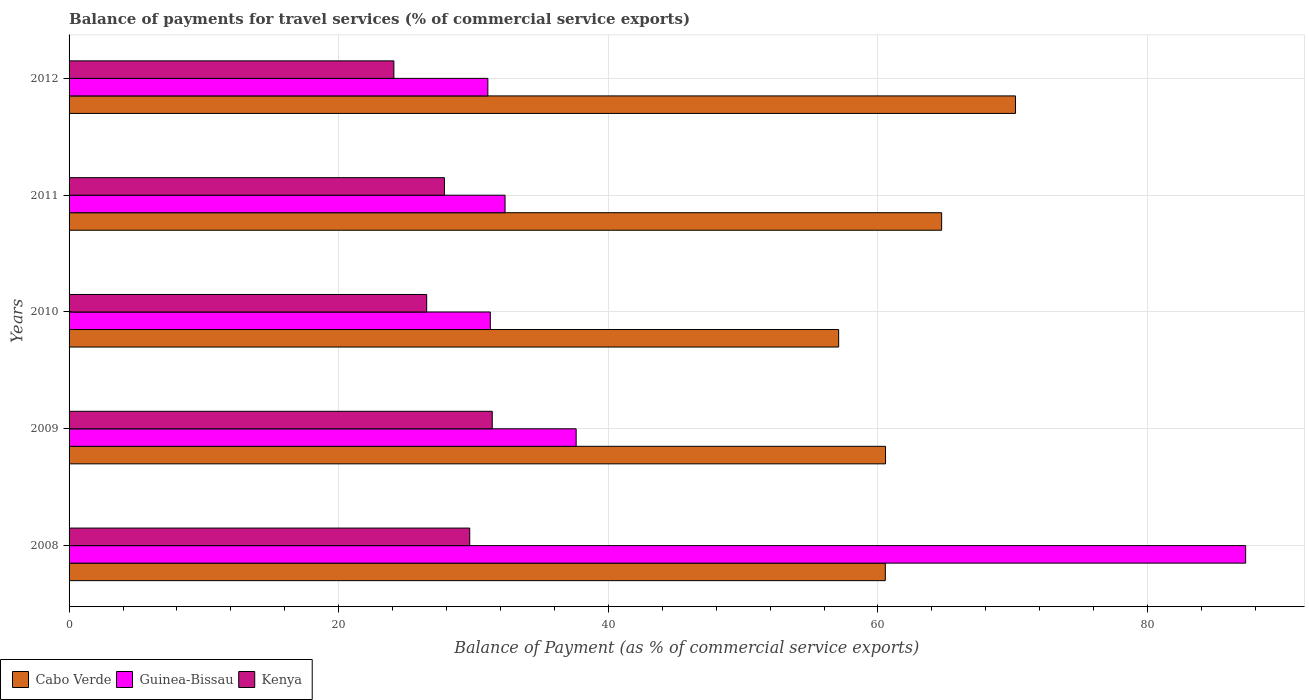How many different coloured bars are there?
Offer a very short reply. 3. What is the label of the 4th group of bars from the top?
Your response must be concise. 2009. What is the balance of payments for travel services in Cabo Verde in 2011?
Your response must be concise. 64.72. Across all years, what is the maximum balance of payments for travel services in Cabo Verde?
Give a very brief answer. 70.2. Across all years, what is the minimum balance of payments for travel services in Guinea-Bissau?
Your answer should be very brief. 31.06. In which year was the balance of payments for travel services in Cabo Verde maximum?
Your answer should be compact. 2012. What is the total balance of payments for travel services in Kenya in the graph?
Your answer should be very brief. 139.57. What is the difference between the balance of payments for travel services in Cabo Verde in 2008 and that in 2012?
Provide a succinct answer. -9.66. What is the difference between the balance of payments for travel services in Kenya in 2010 and the balance of payments for travel services in Cabo Verde in 2009?
Provide a short and direct response. -34.04. What is the average balance of payments for travel services in Guinea-Bissau per year?
Make the answer very short. 43.91. In the year 2010, what is the difference between the balance of payments for travel services in Kenya and balance of payments for travel services in Guinea-Bissau?
Your answer should be very brief. -4.72. In how many years, is the balance of payments for travel services in Kenya greater than 68 %?
Your answer should be compact. 0. What is the ratio of the balance of payments for travel services in Cabo Verde in 2008 to that in 2012?
Make the answer very short. 0.86. Is the balance of payments for travel services in Kenya in 2008 less than that in 2011?
Your answer should be very brief. No. Is the difference between the balance of payments for travel services in Kenya in 2009 and 2012 greater than the difference between the balance of payments for travel services in Guinea-Bissau in 2009 and 2012?
Your response must be concise. Yes. What is the difference between the highest and the second highest balance of payments for travel services in Kenya?
Make the answer very short. 1.67. What is the difference between the highest and the lowest balance of payments for travel services in Cabo Verde?
Keep it short and to the point. 13.12. In how many years, is the balance of payments for travel services in Kenya greater than the average balance of payments for travel services in Kenya taken over all years?
Ensure brevity in your answer.  2. Is the sum of the balance of payments for travel services in Kenya in 2008 and 2012 greater than the maximum balance of payments for travel services in Guinea-Bissau across all years?
Make the answer very short. No. What does the 1st bar from the top in 2009 represents?
Make the answer very short. Kenya. What does the 1st bar from the bottom in 2012 represents?
Give a very brief answer. Cabo Verde. How many bars are there?
Your answer should be very brief. 15. Are all the bars in the graph horizontal?
Offer a very short reply. Yes. Are the values on the major ticks of X-axis written in scientific E-notation?
Offer a terse response. No. Does the graph contain any zero values?
Offer a very short reply. No. How many legend labels are there?
Provide a short and direct response. 3. How are the legend labels stacked?
Ensure brevity in your answer.  Horizontal. What is the title of the graph?
Your answer should be very brief. Balance of payments for travel services (% of commercial service exports). What is the label or title of the X-axis?
Provide a short and direct response. Balance of Payment (as % of commercial service exports). What is the Balance of Payment (as % of commercial service exports) of Cabo Verde in 2008?
Give a very brief answer. 60.55. What is the Balance of Payment (as % of commercial service exports) of Guinea-Bissau in 2008?
Your answer should be very brief. 87.27. What is the Balance of Payment (as % of commercial service exports) of Kenya in 2008?
Your answer should be compact. 29.72. What is the Balance of Payment (as % of commercial service exports) in Cabo Verde in 2009?
Make the answer very short. 60.56. What is the Balance of Payment (as % of commercial service exports) in Guinea-Bissau in 2009?
Offer a very short reply. 37.61. What is the Balance of Payment (as % of commercial service exports) of Kenya in 2009?
Make the answer very short. 31.39. What is the Balance of Payment (as % of commercial service exports) in Cabo Verde in 2010?
Ensure brevity in your answer.  57.08. What is the Balance of Payment (as % of commercial service exports) of Guinea-Bissau in 2010?
Give a very brief answer. 31.25. What is the Balance of Payment (as % of commercial service exports) of Kenya in 2010?
Ensure brevity in your answer.  26.53. What is the Balance of Payment (as % of commercial service exports) of Cabo Verde in 2011?
Keep it short and to the point. 64.72. What is the Balance of Payment (as % of commercial service exports) in Guinea-Bissau in 2011?
Make the answer very short. 32.34. What is the Balance of Payment (as % of commercial service exports) in Kenya in 2011?
Offer a terse response. 27.84. What is the Balance of Payment (as % of commercial service exports) in Cabo Verde in 2012?
Offer a very short reply. 70.2. What is the Balance of Payment (as % of commercial service exports) in Guinea-Bissau in 2012?
Your answer should be compact. 31.06. What is the Balance of Payment (as % of commercial service exports) in Kenya in 2012?
Your answer should be compact. 24.09. Across all years, what is the maximum Balance of Payment (as % of commercial service exports) of Cabo Verde?
Provide a succinct answer. 70.2. Across all years, what is the maximum Balance of Payment (as % of commercial service exports) of Guinea-Bissau?
Keep it short and to the point. 87.27. Across all years, what is the maximum Balance of Payment (as % of commercial service exports) in Kenya?
Keep it short and to the point. 31.39. Across all years, what is the minimum Balance of Payment (as % of commercial service exports) in Cabo Verde?
Provide a succinct answer. 57.08. Across all years, what is the minimum Balance of Payment (as % of commercial service exports) in Guinea-Bissau?
Provide a short and direct response. 31.06. Across all years, what is the minimum Balance of Payment (as % of commercial service exports) of Kenya?
Provide a short and direct response. 24.09. What is the total Balance of Payment (as % of commercial service exports) of Cabo Verde in the graph?
Offer a terse response. 313.12. What is the total Balance of Payment (as % of commercial service exports) of Guinea-Bissau in the graph?
Make the answer very short. 219.54. What is the total Balance of Payment (as % of commercial service exports) in Kenya in the graph?
Provide a short and direct response. 139.57. What is the difference between the Balance of Payment (as % of commercial service exports) in Cabo Verde in 2008 and that in 2009?
Provide a succinct answer. -0.02. What is the difference between the Balance of Payment (as % of commercial service exports) of Guinea-Bissau in 2008 and that in 2009?
Provide a succinct answer. 49.66. What is the difference between the Balance of Payment (as % of commercial service exports) of Kenya in 2008 and that in 2009?
Provide a short and direct response. -1.67. What is the difference between the Balance of Payment (as % of commercial service exports) of Cabo Verde in 2008 and that in 2010?
Your response must be concise. 3.46. What is the difference between the Balance of Payment (as % of commercial service exports) of Guinea-Bissau in 2008 and that in 2010?
Ensure brevity in your answer.  56.03. What is the difference between the Balance of Payment (as % of commercial service exports) of Kenya in 2008 and that in 2010?
Make the answer very short. 3.19. What is the difference between the Balance of Payment (as % of commercial service exports) of Cabo Verde in 2008 and that in 2011?
Provide a succinct answer. -4.18. What is the difference between the Balance of Payment (as % of commercial service exports) of Guinea-Bissau in 2008 and that in 2011?
Ensure brevity in your answer.  54.94. What is the difference between the Balance of Payment (as % of commercial service exports) in Kenya in 2008 and that in 2011?
Provide a succinct answer. 1.88. What is the difference between the Balance of Payment (as % of commercial service exports) of Cabo Verde in 2008 and that in 2012?
Provide a short and direct response. -9.66. What is the difference between the Balance of Payment (as % of commercial service exports) of Guinea-Bissau in 2008 and that in 2012?
Provide a short and direct response. 56.21. What is the difference between the Balance of Payment (as % of commercial service exports) of Kenya in 2008 and that in 2012?
Give a very brief answer. 5.63. What is the difference between the Balance of Payment (as % of commercial service exports) of Cabo Verde in 2009 and that in 2010?
Ensure brevity in your answer.  3.48. What is the difference between the Balance of Payment (as % of commercial service exports) in Guinea-Bissau in 2009 and that in 2010?
Your answer should be very brief. 6.37. What is the difference between the Balance of Payment (as % of commercial service exports) of Kenya in 2009 and that in 2010?
Your answer should be very brief. 4.86. What is the difference between the Balance of Payment (as % of commercial service exports) of Cabo Verde in 2009 and that in 2011?
Offer a terse response. -4.16. What is the difference between the Balance of Payment (as % of commercial service exports) of Guinea-Bissau in 2009 and that in 2011?
Your answer should be very brief. 5.27. What is the difference between the Balance of Payment (as % of commercial service exports) in Kenya in 2009 and that in 2011?
Provide a short and direct response. 3.55. What is the difference between the Balance of Payment (as % of commercial service exports) of Cabo Verde in 2009 and that in 2012?
Offer a terse response. -9.64. What is the difference between the Balance of Payment (as % of commercial service exports) in Guinea-Bissau in 2009 and that in 2012?
Your response must be concise. 6.55. What is the difference between the Balance of Payment (as % of commercial service exports) in Kenya in 2009 and that in 2012?
Offer a terse response. 7.3. What is the difference between the Balance of Payment (as % of commercial service exports) of Cabo Verde in 2010 and that in 2011?
Your answer should be very brief. -7.64. What is the difference between the Balance of Payment (as % of commercial service exports) of Guinea-Bissau in 2010 and that in 2011?
Your answer should be very brief. -1.09. What is the difference between the Balance of Payment (as % of commercial service exports) in Kenya in 2010 and that in 2011?
Make the answer very short. -1.32. What is the difference between the Balance of Payment (as % of commercial service exports) of Cabo Verde in 2010 and that in 2012?
Offer a very short reply. -13.12. What is the difference between the Balance of Payment (as % of commercial service exports) in Guinea-Bissau in 2010 and that in 2012?
Provide a succinct answer. 0.18. What is the difference between the Balance of Payment (as % of commercial service exports) in Kenya in 2010 and that in 2012?
Offer a very short reply. 2.43. What is the difference between the Balance of Payment (as % of commercial service exports) of Cabo Verde in 2011 and that in 2012?
Your answer should be compact. -5.48. What is the difference between the Balance of Payment (as % of commercial service exports) of Guinea-Bissau in 2011 and that in 2012?
Your answer should be compact. 1.28. What is the difference between the Balance of Payment (as % of commercial service exports) of Kenya in 2011 and that in 2012?
Make the answer very short. 3.75. What is the difference between the Balance of Payment (as % of commercial service exports) in Cabo Verde in 2008 and the Balance of Payment (as % of commercial service exports) in Guinea-Bissau in 2009?
Ensure brevity in your answer.  22.93. What is the difference between the Balance of Payment (as % of commercial service exports) of Cabo Verde in 2008 and the Balance of Payment (as % of commercial service exports) of Kenya in 2009?
Make the answer very short. 29.16. What is the difference between the Balance of Payment (as % of commercial service exports) of Guinea-Bissau in 2008 and the Balance of Payment (as % of commercial service exports) of Kenya in 2009?
Keep it short and to the point. 55.88. What is the difference between the Balance of Payment (as % of commercial service exports) in Cabo Verde in 2008 and the Balance of Payment (as % of commercial service exports) in Guinea-Bissau in 2010?
Offer a terse response. 29.3. What is the difference between the Balance of Payment (as % of commercial service exports) in Cabo Verde in 2008 and the Balance of Payment (as % of commercial service exports) in Kenya in 2010?
Provide a short and direct response. 34.02. What is the difference between the Balance of Payment (as % of commercial service exports) of Guinea-Bissau in 2008 and the Balance of Payment (as % of commercial service exports) of Kenya in 2010?
Ensure brevity in your answer.  60.75. What is the difference between the Balance of Payment (as % of commercial service exports) in Cabo Verde in 2008 and the Balance of Payment (as % of commercial service exports) in Guinea-Bissau in 2011?
Your answer should be very brief. 28.21. What is the difference between the Balance of Payment (as % of commercial service exports) of Cabo Verde in 2008 and the Balance of Payment (as % of commercial service exports) of Kenya in 2011?
Offer a terse response. 32.7. What is the difference between the Balance of Payment (as % of commercial service exports) of Guinea-Bissau in 2008 and the Balance of Payment (as % of commercial service exports) of Kenya in 2011?
Make the answer very short. 59.43. What is the difference between the Balance of Payment (as % of commercial service exports) of Cabo Verde in 2008 and the Balance of Payment (as % of commercial service exports) of Guinea-Bissau in 2012?
Make the answer very short. 29.48. What is the difference between the Balance of Payment (as % of commercial service exports) in Cabo Verde in 2008 and the Balance of Payment (as % of commercial service exports) in Kenya in 2012?
Your response must be concise. 36.45. What is the difference between the Balance of Payment (as % of commercial service exports) of Guinea-Bissau in 2008 and the Balance of Payment (as % of commercial service exports) of Kenya in 2012?
Offer a terse response. 63.18. What is the difference between the Balance of Payment (as % of commercial service exports) in Cabo Verde in 2009 and the Balance of Payment (as % of commercial service exports) in Guinea-Bissau in 2010?
Provide a succinct answer. 29.32. What is the difference between the Balance of Payment (as % of commercial service exports) in Cabo Verde in 2009 and the Balance of Payment (as % of commercial service exports) in Kenya in 2010?
Your answer should be very brief. 34.04. What is the difference between the Balance of Payment (as % of commercial service exports) of Guinea-Bissau in 2009 and the Balance of Payment (as % of commercial service exports) of Kenya in 2010?
Make the answer very short. 11.09. What is the difference between the Balance of Payment (as % of commercial service exports) of Cabo Verde in 2009 and the Balance of Payment (as % of commercial service exports) of Guinea-Bissau in 2011?
Ensure brevity in your answer.  28.22. What is the difference between the Balance of Payment (as % of commercial service exports) of Cabo Verde in 2009 and the Balance of Payment (as % of commercial service exports) of Kenya in 2011?
Your answer should be compact. 32.72. What is the difference between the Balance of Payment (as % of commercial service exports) in Guinea-Bissau in 2009 and the Balance of Payment (as % of commercial service exports) in Kenya in 2011?
Offer a terse response. 9.77. What is the difference between the Balance of Payment (as % of commercial service exports) of Cabo Verde in 2009 and the Balance of Payment (as % of commercial service exports) of Guinea-Bissau in 2012?
Provide a succinct answer. 29.5. What is the difference between the Balance of Payment (as % of commercial service exports) of Cabo Verde in 2009 and the Balance of Payment (as % of commercial service exports) of Kenya in 2012?
Offer a very short reply. 36.47. What is the difference between the Balance of Payment (as % of commercial service exports) of Guinea-Bissau in 2009 and the Balance of Payment (as % of commercial service exports) of Kenya in 2012?
Make the answer very short. 13.52. What is the difference between the Balance of Payment (as % of commercial service exports) of Cabo Verde in 2010 and the Balance of Payment (as % of commercial service exports) of Guinea-Bissau in 2011?
Provide a succinct answer. 24.75. What is the difference between the Balance of Payment (as % of commercial service exports) in Cabo Verde in 2010 and the Balance of Payment (as % of commercial service exports) in Kenya in 2011?
Your answer should be very brief. 29.24. What is the difference between the Balance of Payment (as % of commercial service exports) in Guinea-Bissau in 2010 and the Balance of Payment (as % of commercial service exports) in Kenya in 2011?
Make the answer very short. 3.4. What is the difference between the Balance of Payment (as % of commercial service exports) in Cabo Verde in 2010 and the Balance of Payment (as % of commercial service exports) in Guinea-Bissau in 2012?
Offer a very short reply. 26.02. What is the difference between the Balance of Payment (as % of commercial service exports) in Cabo Verde in 2010 and the Balance of Payment (as % of commercial service exports) in Kenya in 2012?
Your response must be concise. 32.99. What is the difference between the Balance of Payment (as % of commercial service exports) in Guinea-Bissau in 2010 and the Balance of Payment (as % of commercial service exports) in Kenya in 2012?
Your answer should be compact. 7.15. What is the difference between the Balance of Payment (as % of commercial service exports) in Cabo Verde in 2011 and the Balance of Payment (as % of commercial service exports) in Guinea-Bissau in 2012?
Ensure brevity in your answer.  33.66. What is the difference between the Balance of Payment (as % of commercial service exports) in Cabo Verde in 2011 and the Balance of Payment (as % of commercial service exports) in Kenya in 2012?
Make the answer very short. 40.63. What is the difference between the Balance of Payment (as % of commercial service exports) of Guinea-Bissau in 2011 and the Balance of Payment (as % of commercial service exports) of Kenya in 2012?
Offer a very short reply. 8.25. What is the average Balance of Payment (as % of commercial service exports) in Cabo Verde per year?
Your answer should be very brief. 62.62. What is the average Balance of Payment (as % of commercial service exports) in Guinea-Bissau per year?
Your answer should be very brief. 43.91. What is the average Balance of Payment (as % of commercial service exports) in Kenya per year?
Your answer should be compact. 27.91. In the year 2008, what is the difference between the Balance of Payment (as % of commercial service exports) of Cabo Verde and Balance of Payment (as % of commercial service exports) of Guinea-Bissau?
Your answer should be compact. -26.73. In the year 2008, what is the difference between the Balance of Payment (as % of commercial service exports) in Cabo Verde and Balance of Payment (as % of commercial service exports) in Kenya?
Keep it short and to the point. 30.83. In the year 2008, what is the difference between the Balance of Payment (as % of commercial service exports) in Guinea-Bissau and Balance of Payment (as % of commercial service exports) in Kenya?
Provide a succinct answer. 57.56. In the year 2009, what is the difference between the Balance of Payment (as % of commercial service exports) in Cabo Verde and Balance of Payment (as % of commercial service exports) in Guinea-Bissau?
Keep it short and to the point. 22.95. In the year 2009, what is the difference between the Balance of Payment (as % of commercial service exports) in Cabo Verde and Balance of Payment (as % of commercial service exports) in Kenya?
Your answer should be very brief. 29.17. In the year 2009, what is the difference between the Balance of Payment (as % of commercial service exports) in Guinea-Bissau and Balance of Payment (as % of commercial service exports) in Kenya?
Give a very brief answer. 6.22. In the year 2010, what is the difference between the Balance of Payment (as % of commercial service exports) of Cabo Verde and Balance of Payment (as % of commercial service exports) of Guinea-Bissau?
Offer a terse response. 25.84. In the year 2010, what is the difference between the Balance of Payment (as % of commercial service exports) of Cabo Verde and Balance of Payment (as % of commercial service exports) of Kenya?
Give a very brief answer. 30.56. In the year 2010, what is the difference between the Balance of Payment (as % of commercial service exports) in Guinea-Bissau and Balance of Payment (as % of commercial service exports) in Kenya?
Provide a short and direct response. 4.72. In the year 2011, what is the difference between the Balance of Payment (as % of commercial service exports) of Cabo Verde and Balance of Payment (as % of commercial service exports) of Guinea-Bissau?
Give a very brief answer. 32.39. In the year 2011, what is the difference between the Balance of Payment (as % of commercial service exports) of Cabo Verde and Balance of Payment (as % of commercial service exports) of Kenya?
Your answer should be compact. 36.88. In the year 2011, what is the difference between the Balance of Payment (as % of commercial service exports) in Guinea-Bissau and Balance of Payment (as % of commercial service exports) in Kenya?
Offer a very short reply. 4.5. In the year 2012, what is the difference between the Balance of Payment (as % of commercial service exports) in Cabo Verde and Balance of Payment (as % of commercial service exports) in Guinea-Bissau?
Your answer should be compact. 39.14. In the year 2012, what is the difference between the Balance of Payment (as % of commercial service exports) in Cabo Verde and Balance of Payment (as % of commercial service exports) in Kenya?
Your answer should be compact. 46.11. In the year 2012, what is the difference between the Balance of Payment (as % of commercial service exports) of Guinea-Bissau and Balance of Payment (as % of commercial service exports) of Kenya?
Your answer should be compact. 6.97. What is the ratio of the Balance of Payment (as % of commercial service exports) in Cabo Verde in 2008 to that in 2009?
Ensure brevity in your answer.  1. What is the ratio of the Balance of Payment (as % of commercial service exports) in Guinea-Bissau in 2008 to that in 2009?
Give a very brief answer. 2.32. What is the ratio of the Balance of Payment (as % of commercial service exports) in Kenya in 2008 to that in 2009?
Provide a short and direct response. 0.95. What is the ratio of the Balance of Payment (as % of commercial service exports) in Cabo Verde in 2008 to that in 2010?
Offer a very short reply. 1.06. What is the ratio of the Balance of Payment (as % of commercial service exports) in Guinea-Bissau in 2008 to that in 2010?
Your answer should be very brief. 2.79. What is the ratio of the Balance of Payment (as % of commercial service exports) in Kenya in 2008 to that in 2010?
Your response must be concise. 1.12. What is the ratio of the Balance of Payment (as % of commercial service exports) of Cabo Verde in 2008 to that in 2011?
Your answer should be very brief. 0.94. What is the ratio of the Balance of Payment (as % of commercial service exports) of Guinea-Bissau in 2008 to that in 2011?
Offer a very short reply. 2.7. What is the ratio of the Balance of Payment (as % of commercial service exports) of Kenya in 2008 to that in 2011?
Keep it short and to the point. 1.07. What is the ratio of the Balance of Payment (as % of commercial service exports) of Cabo Verde in 2008 to that in 2012?
Your answer should be compact. 0.86. What is the ratio of the Balance of Payment (as % of commercial service exports) of Guinea-Bissau in 2008 to that in 2012?
Offer a very short reply. 2.81. What is the ratio of the Balance of Payment (as % of commercial service exports) of Kenya in 2008 to that in 2012?
Provide a succinct answer. 1.23. What is the ratio of the Balance of Payment (as % of commercial service exports) in Cabo Verde in 2009 to that in 2010?
Your answer should be compact. 1.06. What is the ratio of the Balance of Payment (as % of commercial service exports) in Guinea-Bissau in 2009 to that in 2010?
Provide a short and direct response. 1.2. What is the ratio of the Balance of Payment (as % of commercial service exports) of Kenya in 2009 to that in 2010?
Make the answer very short. 1.18. What is the ratio of the Balance of Payment (as % of commercial service exports) in Cabo Verde in 2009 to that in 2011?
Provide a succinct answer. 0.94. What is the ratio of the Balance of Payment (as % of commercial service exports) in Guinea-Bissau in 2009 to that in 2011?
Give a very brief answer. 1.16. What is the ratio of the Balance of Payment (as % of commercial service exports) in Kenya in 2009 to that in 2011?
Offer a terse response. 1.13. What is the ratio of the Balance of Payment (as % of commercial service exports) of Cabo Verde in 2009 to that in 2012?
Give a very brief answer. 0.86. What is the ratio of the Balance of Payment (as % of commercial service exports) of Guinea-Bissau in 2009 to that in 2012?
Keep it short and to the point. 1.21. What is the ratio of the Balance of Payment (as % of commercial service exports) of Kenya in 2009 to that in 2012?
Ensure brevity in your answer.  1.3. What is the ratio of the Balance of Payment (as % of commercial service exports) of Cabo Verde in 2010 to that in 2011?
Provide a short and direct response. 0.88. What is the ratio of the Balance of Payment (as % of commercial service exports) of Guinea-Bissau in 2010 to that in 2011?
Your answer should be very brief. 0.97. What is the ratio of the Balance of Payment (as % of commercial service exports) in Kenya in 2010 to that in 2011?
Provide a succinct answer. 0.95. What is the ratio of the Balance of Payment (as % of commercial service exports) of Cabo Verde in 2010 to that in 2012?
Provide a succinct answer. 0.81. What is the ratio of the Balance of Payment (as % of commercial service exports) of Guinea-Bissau in 2010 to that in 2012?
Your response must be concise. 1.01. What is the ratio of the Balance of Payment (as % of commercial service exports) in Kenya in 2010 to that in 2012?
Offer a very short reply. 1.1. What is the ratio of the Balance of Payment (as % of commercial service exports) of Cabo Verde in 2011 to that in 2012?
Your answer should be very brief. 0.92. What is the ratio of the Balance of Payment (as % of commercial service exports) in Guinea-Bissau in 2011 to that in 2012?
Your answer should be compact. 1.04. What is the ratio of the Balance of Payment (as % of commercial service exports) of Kenya in 2011 to that in 2012?
Provide a short and direct response. 1.16. What is the difference between the highest and the second highest Balance of Payment (as % of commercial service exports) in Cabo Verde?
Keep it short and to the point. 5.48. What is the difference between the highest and the second highest Balance of Payment (as % of commercial service exports) in Guinea-Bissau?
Keep it short and to the point. 49.66. What is the difference between the highest and the second highest Balance of Payment (as % of commercial service exports) in Kenya?
Your response must be concise. 1.67. What is the difference between the highest and the lowest Balance of Payment (as % of commercial service exports) in Cabo Verde?
Make the answer very short. 13.12. What is the difference between the highest and the lowest Balance of Payment (as % of commercial service exports) in Guinea-Bissau?
Your answer should be compact. 56.21. What is the difference between the highest and the lowest Balance of Payment (as % of commercial service exports) of Kenya?
Your answer should be very brief. 7.3. 